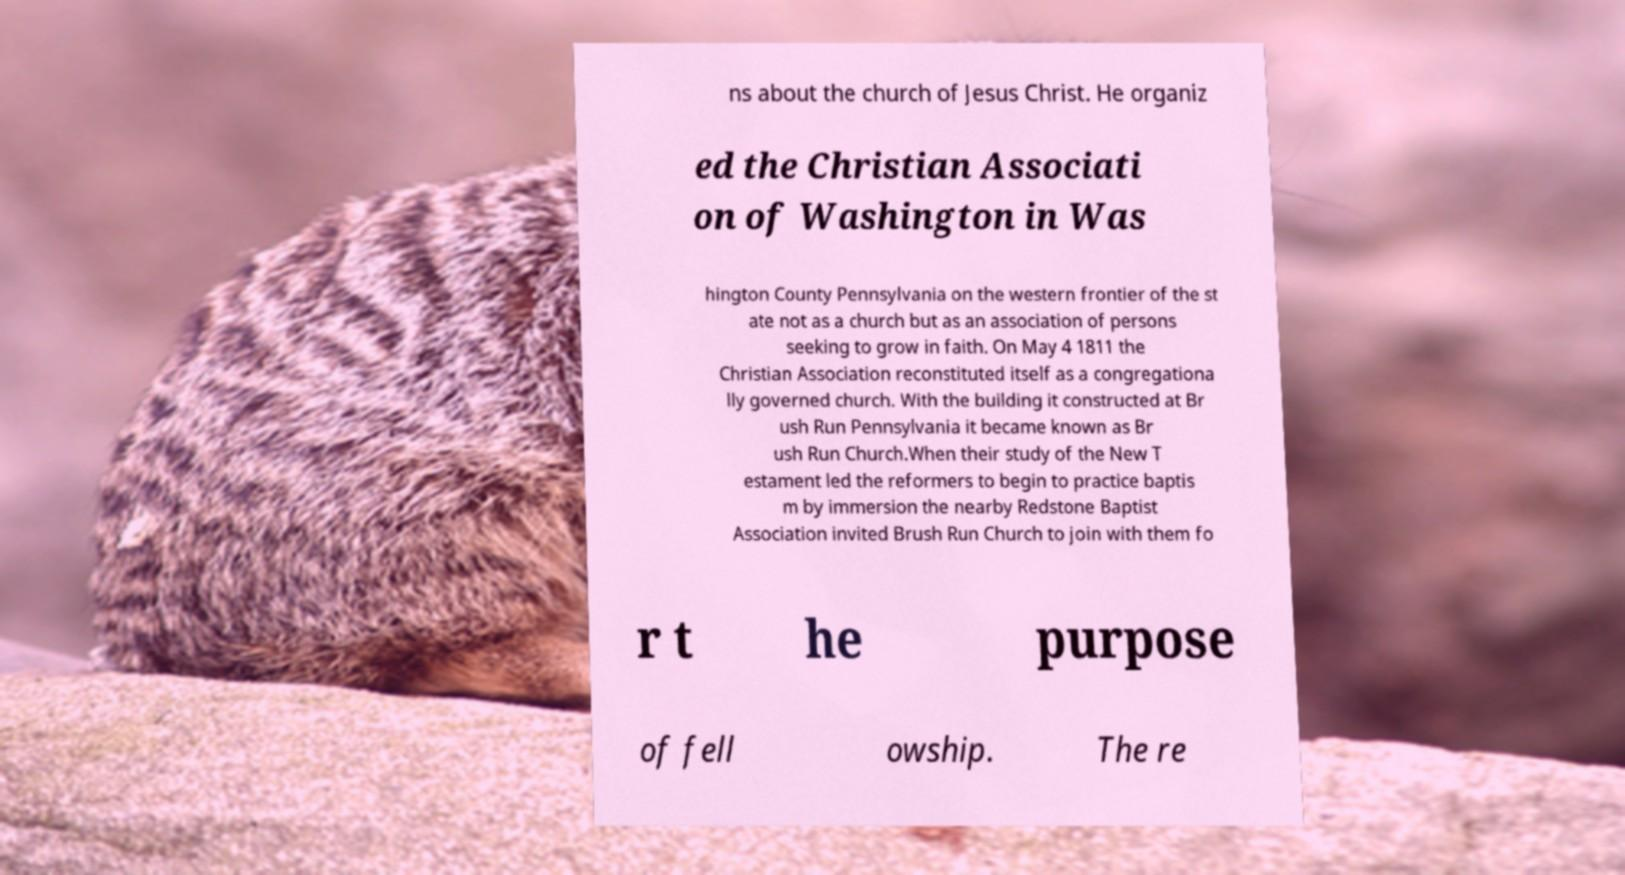There's text embedded in this image that I need extracted. Can you transcribe it verbatim? ns about the church of Jesus Christ. He organiz ed the Christian Associati on of Washington in Was hington County Pennsylvania on the western frontier of the st ate not as a church but as an association of persons seeking to grow in faith. On May 4 1811 the Christian Association reconstituted itself as a congregationa lly governed church. With the building it constructed at Br ush Run Pennsylvania it became known as Br ush Run Church.When their study of the New T estament led the reformers to begin to practice baptis m by immersion the nearby Redstone Baptist Association invited Brush Run Church to join with them fo r t he purpose of fell owship. The re 